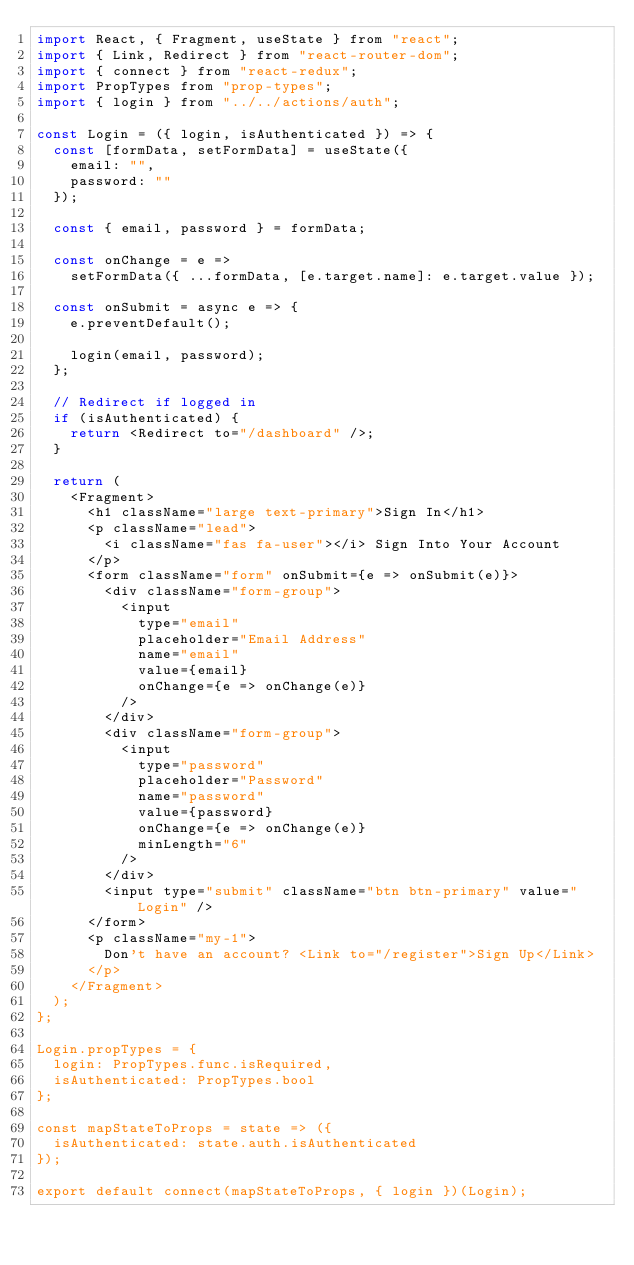<code> <loc_0><loc_0><loc_500><loc_500><_JavaScript_>import React, { Fragment, useState } from "react";
import { Link, Redirect } from "react-router-dom";
import { connect } from "react-redux";
import PropTypes from "prop-types";
import { login } from "../../actions/auth";

const Login = ({ login, isAuthenticated }) => {
  const [formData, setFormData] = useState({
    email: "",
    password: ""
  });

  const { email, password } = formData;

  const onChange = e =>
    setFormData({ ...formData, [e.target.name]: e.target.value });

  const onSubmit = async e => {
    e.preventDefault();

    login(email, password);
  };

  // Redirect if logged in
  if (isAuthenticated) {
    return <Redirect to="/dashboard" />;
  }

  return (
    <Fragment>
      <h1 className="large text-primary">Sign In</h1>
      <p className="lead">
        <i className="fas fa-user"></i> Sign Into Your Account
      </p>
      <form className="form" onSubmit={e => onSubmit(e)}>
        <div className="form-group">
          <input
            type="email"
            placeholder="Email Address"
            name="email"
            value={email}
            onChange={e => onChange(e)}
          />
        </div>
        <div className="form-group">
          <input
            type="password"
            placeholder="Password"
            name="password"
            value={password}
            onChange={e => onChange(e)}
            minLength="6"
          />
        </div>
        <input type="submit" className="btn btn-primary" value="Login" />
      </form>
      <p className="my-1">
        Don't have an account? <Link to="/register">Sign Up</Link>
      </p>
    </Fragment>
  );
};

Login.propTypes = {
  login: PropTypes.func.isRequired,
  isAuthenticated: PropTypes.bool
};

const mapStateToProps = state => ({
  isAuthenticated: state.auth.isAuthenticated
});

export default connect(mapStateToProps, { login })(Login);
</code> 